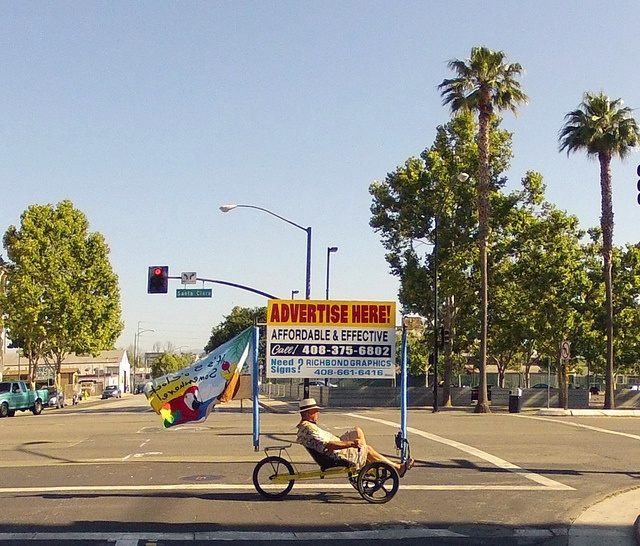Describe the objects in this image and their specific colors. I can see people in darkgray, maroon, tan, khaki, and black tones, truck in darkgray, black, and teal tones, traffic light in darkgray, black, navy, and purple tones, car in darkgray, gray, black, and tan tones, and car in darkgray, gray, black, and lightgray tones in this image. 